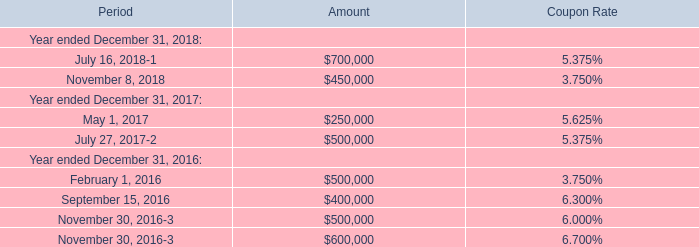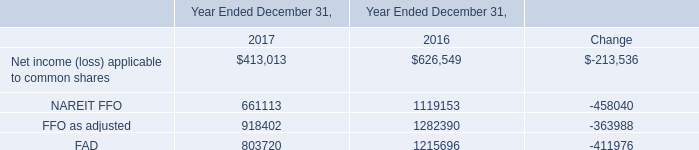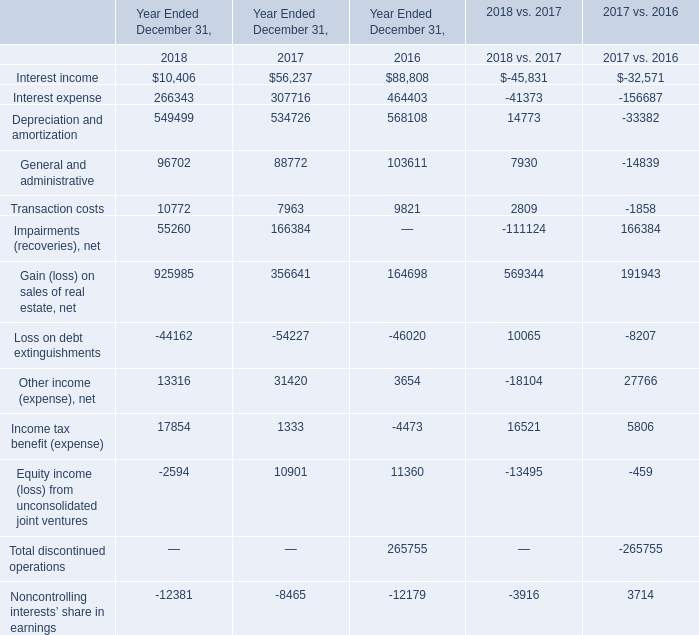What is the sum of the Interest expense in the years where Interest income is positive for Year Ended December 31,? 
Computations: ((266343 + 307716) + 464403)
Answer: 1038462.0. 